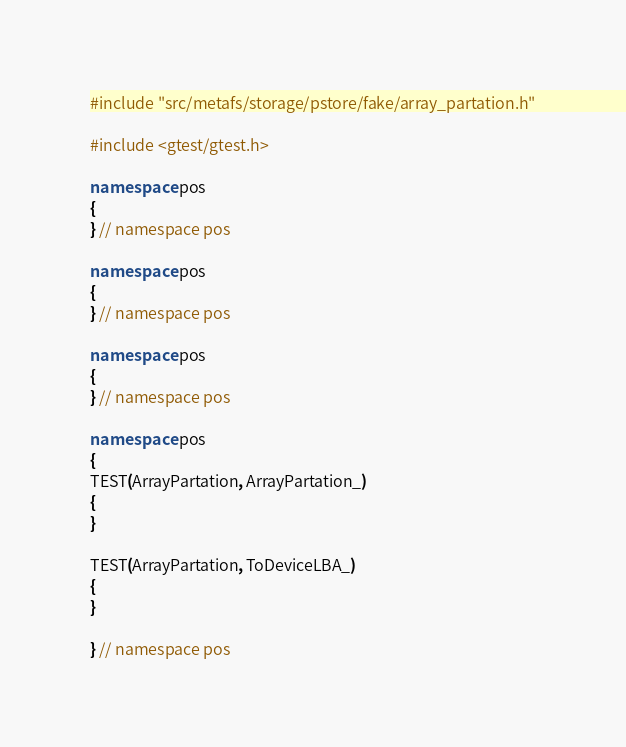Convert code to text. <code><loc_0><loc_0><loc_500><loc_500><_C++_>#include "src/metafs/storage/pstore/fake/array_partation.h"

#include <gtest/gtest.h>

namespace pos
{
} // namespace pos

namespace pos
{
} // namespace pos

namespace pos
{
} // namespace pos

namespace pos
{
TEST(ArrayPartation, ArrayPartation_)
{
}

TEST(ArrayPartation, ToDeviceLBA_)
{
}

} // namespace pos
</code> 